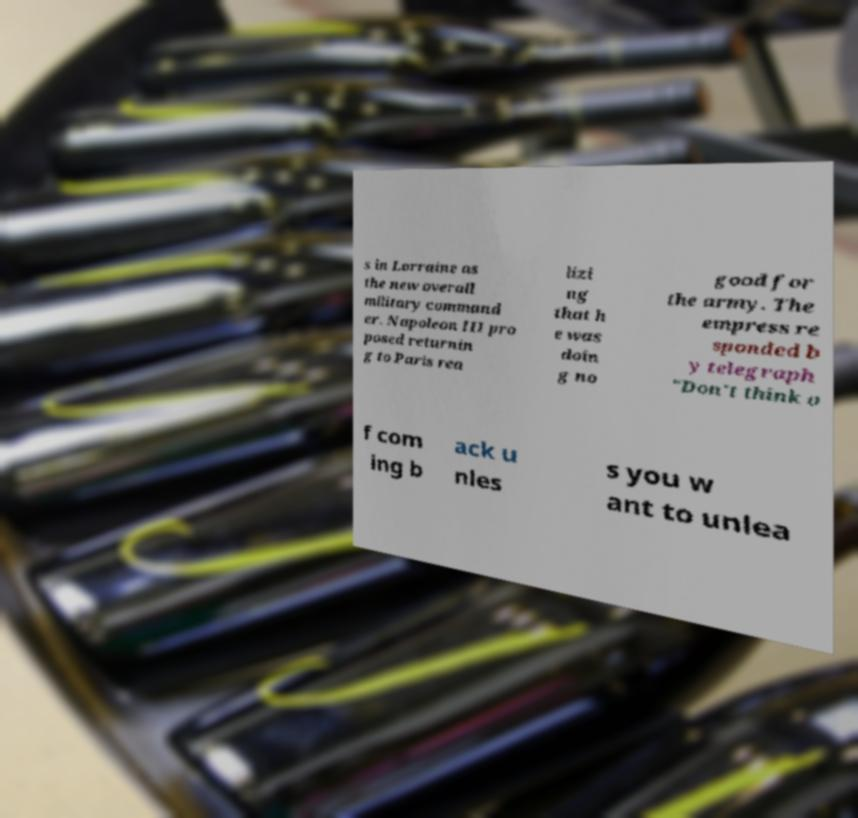Please identify and transcribe the text found in this image. s in Lorraine as the new overall military command er. Napoleon III pro posed returnin g to Paris rea lizi ng that h e was doin g no good for the army. The empress re sponded b y telegraph "Don't think o f com ing b ack u nles s you w ant to unlea 